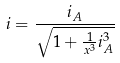Convert formula to latex. <formula><loc_0><loc_0><loc_500><loc_500>i = \frac { i _ { A } } { \sqrt { 1 + \frac { 1 } { x ^ { 3 } } i _ { A } ^ { 3 } } }</formula> 